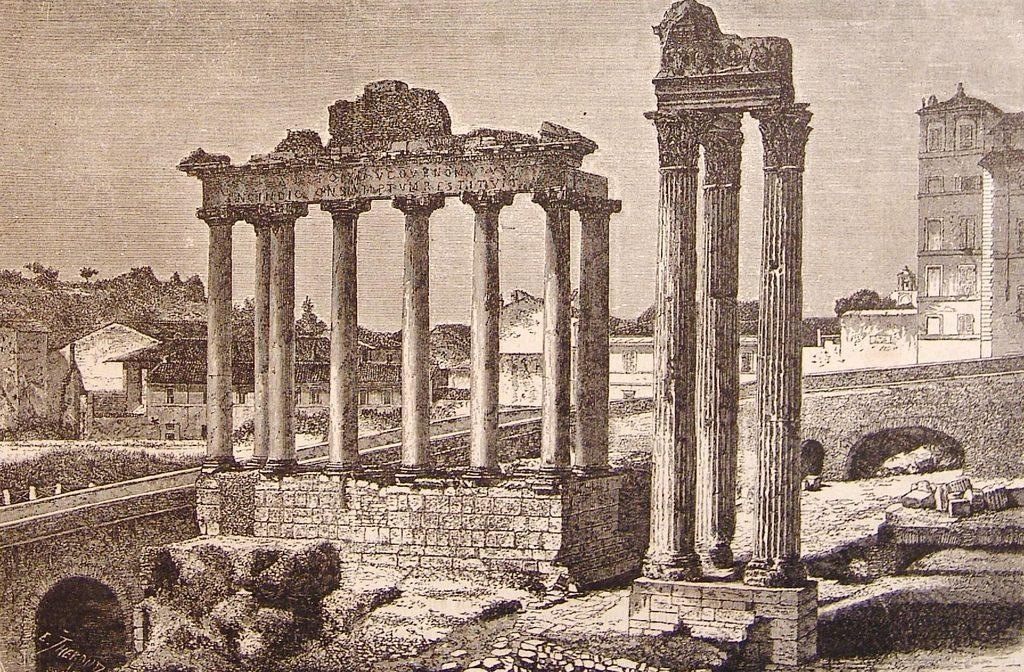What type of structure is the main subject of the image? The image contains a monument. What other types of structures can be seen in the image? The image contains buildings. What architectural feature is present in the image? There is a bridge in the image. What type of cloth is draped over the monument in the image? There is no cloth draped over the monument in the image. What sound can be heard coming from the bells in the image? There are no bells present in the image. 